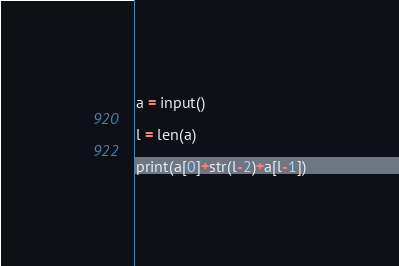Convert code to text. <code><loc_0><loc_0><loc_500><loc_500><_Python_>a = input()

l = len(a)

print(a[0]+str(l-2)+a[l-1])</code> 